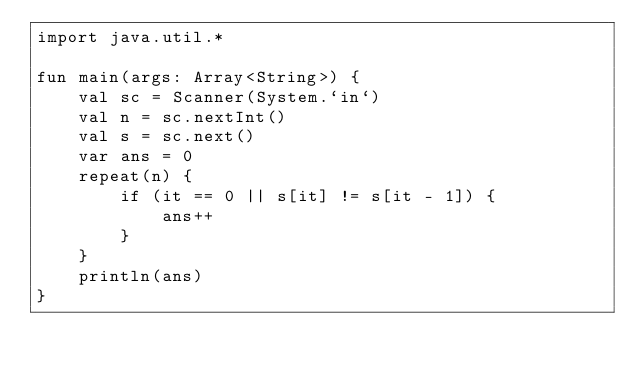Convert code to text. <code><loc_0><loc_0><loc_500><loc_500><_Kotlin_>import java.util.*

fun main(args: Array<String>) {
    val sc = Scanner(System.`in`)
    val n = sc.nextInt()
    val s = sc.next()
    var ans = 0
    repeat(n) {
        if (it == 0 || s[it] != s[it - 1]) {
            ans++
        }
    }
    println(ans)
}</code> 